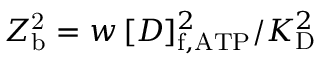Convert formula to latex. <formula><loc_0><loc_0><loc_500><loc_500>Z _ { b } ^ { 2 } = w \, [ D ] _ { f , A T P } ^ { 2 } / K _ { D } ^ { 2 }</formula> 